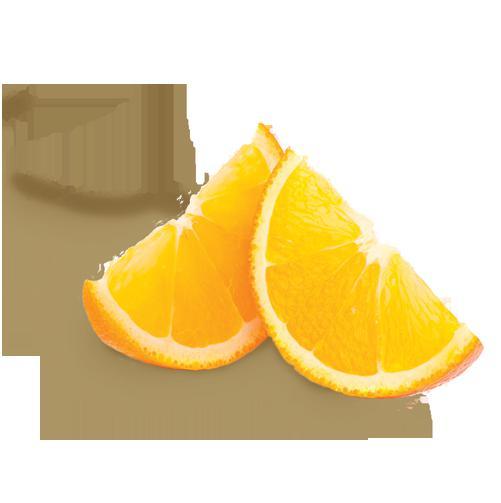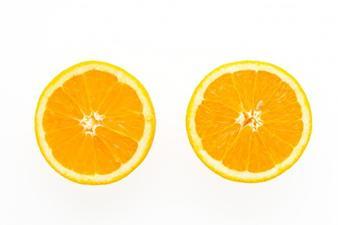The first image is the image on the left, the second image is the image on the right. Assess this claim about the two images: "There is one whole uncut orange in the left image.". Correct or not? Answer yes or no. No. 